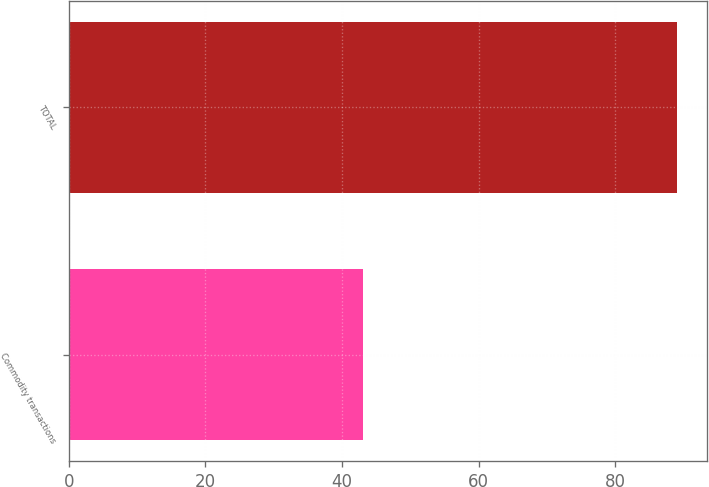Convert chart to OTSL. <chart><loc_0><loc_0><loc_500><loc_500><bar_chart><fcel>Commodity transactions<fcel>TOTAL<nl><fcel>43<fcel>89<nl></chart> 